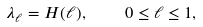<formula> <loc_0><loc_0><loc_500><loc_500>\lambda _ { \ell } = H ( \ell ) , \quad 0 \leq \ell \leq 1 ,</formula> 